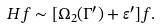Convert formula to latex. <formula><loc_0><loc_0><loc_500><loc_500>H f \sim [ \Omega _ { 2 } ( \Gamma ^ { \prime } ) + { \varepsilon } ^ { \prime } ] f .</formula> 